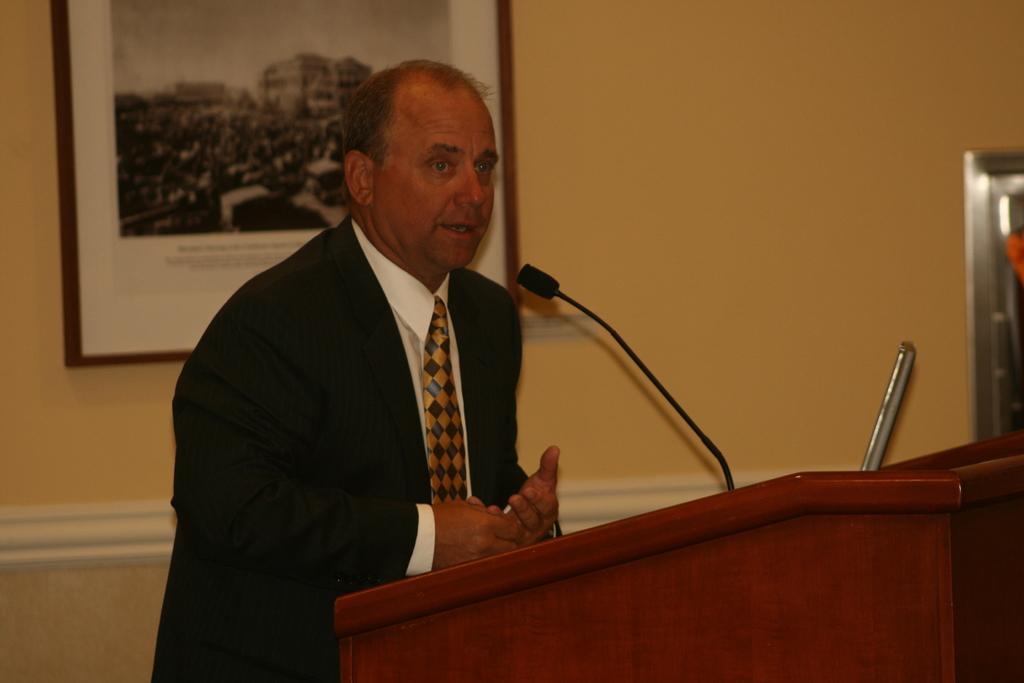How would you summarize this image in a sentence or two? This image consists of a man wearing suit. He is standing near the podium and talking. In the background, there is a wall along with a frame. He is also wearing a tie. 